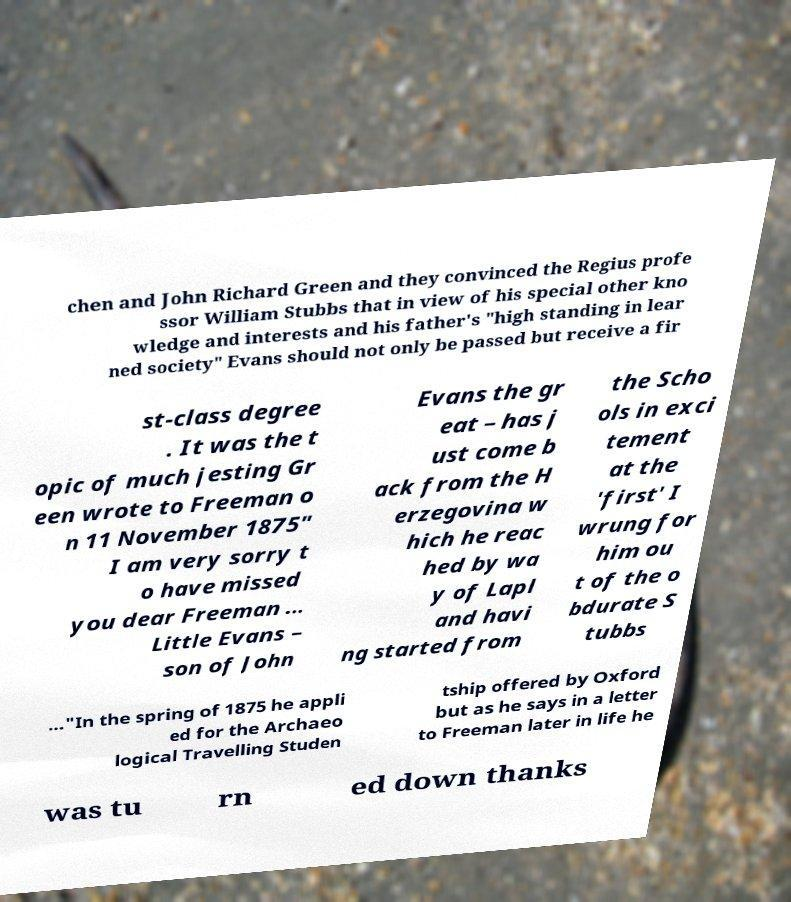For documentation purposes, I need the text within this image transcribed. Could you provide that? chen and John Richard Green and they convinced the Regius profe ssor William Stubbs that in view of his special other kno wledge and interests and his father's "high standing in lear ned society" Evans should not only be passed but receive a fir st-class degree . It was the t opic of much jesting Gr een wrote to Freeman o n 11 November 1875" I am very sorry t o have missed you dear Freeman ... Little Evans – son of John Evans the gr eat – has j ust come b ack from the H erzegovina w hich he reac hed by wa y of Lapl and havi ng started from the Scho ols in exci tement at the 'first' I wrung for him ou t of the o bdurate S tubbs ..."In the spring of 1875 he appli ed for the Archaeo logical Travelling Studen tship offered by Oxford but as he says in a letter to Freeman later in life he was tu rn ed down thanks 